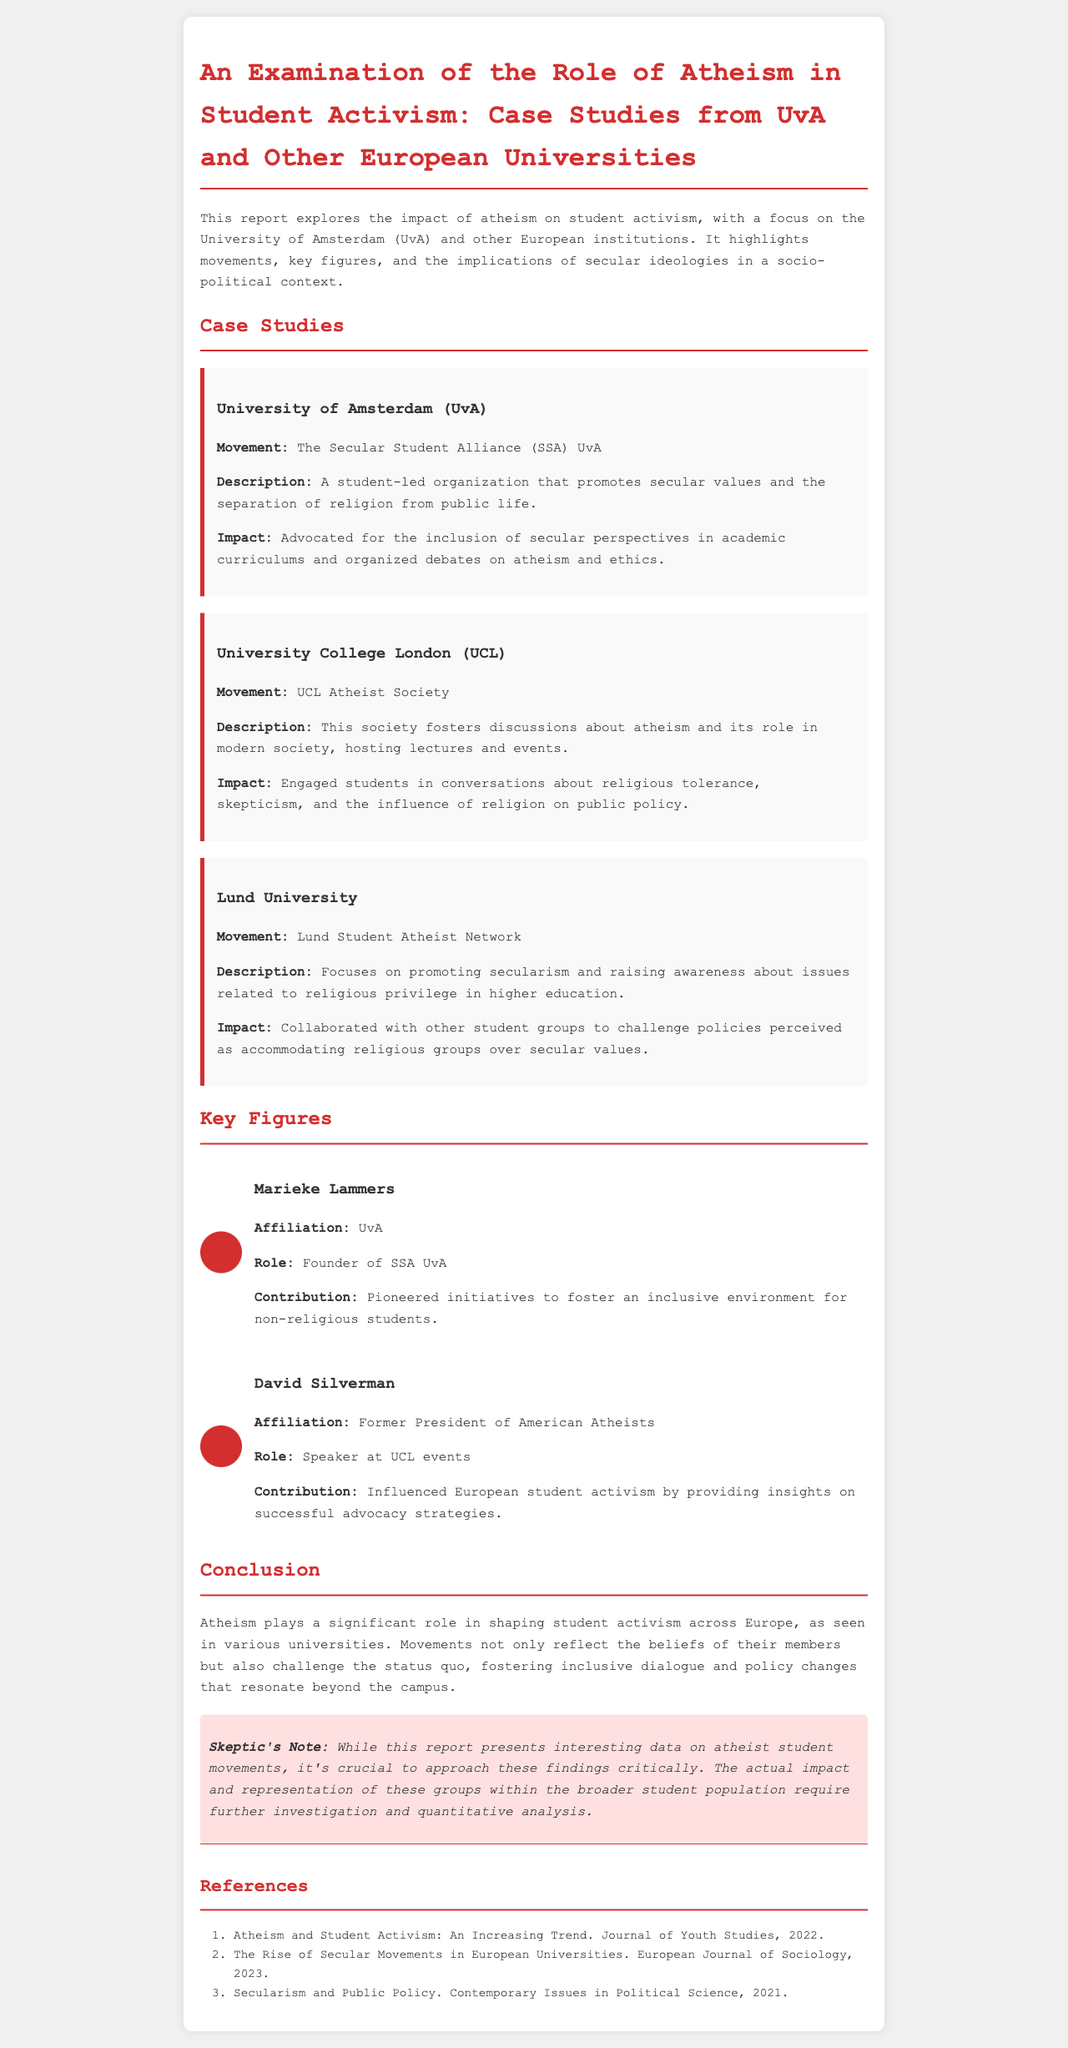What is the title of the report? The title of the report is prominently stated at the top of the document.
Answer: An Examination of the Role of Atheism in Student Activism: Case Studies from UvA and Other European Universities Which organization is associated with UvA? The report mentions a specific student-led organization at UvA that promotes secular values.
Answer: The Secular Student Alliance (SSA) UvA Who is the founder of SSA UvA? The report includes a section on key figures, listing their roles and contributions to student activism.
Answer: Marieke Lammers What is a key focus of the UCL Atheist Society? The description of the UCL Atheist Society provides insight into its main activities and discussions.
Answer: Discussions about atheism and its role in modern society What collaboration effort did Lund Student Atheist Network engage in? The report describes the impact of the Lund Student Atheist Network regarding policies related to religious privilege.
Answer: Collaborated with other student groups to challenge policies What is noted as a Skeptic's Note in the report? The document includes a specific section that emphasizes a critical perspective on the findings presented.
Answer: The actual impact and representation of these groups within the broader student population require further investigation and quantitative analysis 